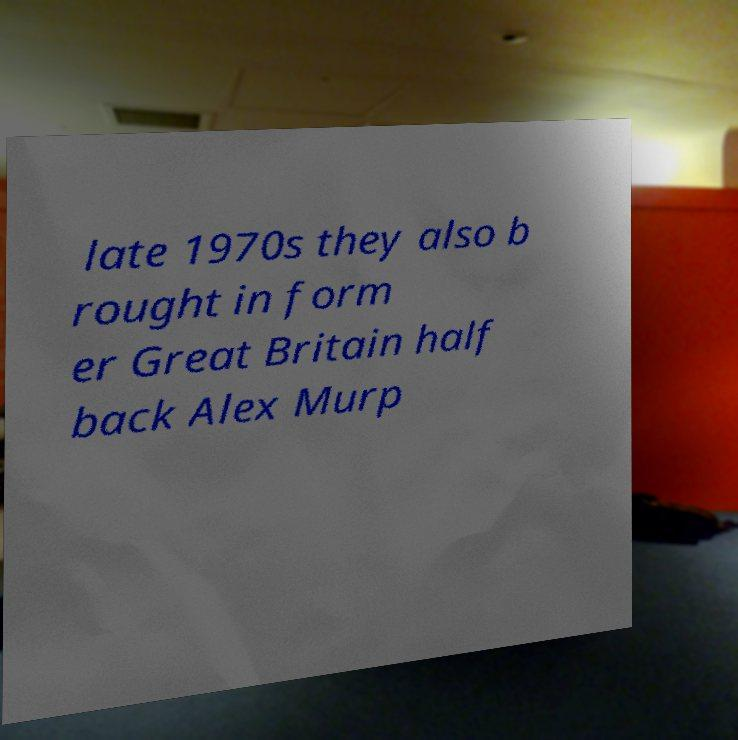Can you read and provide the text displayed in the image?This photo seems to have some interesting text. Can you extract and type it out for me? late 1970s they also b rought in form er Great Britain half back Alex Murp 